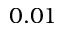Convert formula to latex. <formula><loc_0><loc_0><loc_500><loc_500>0 . 0 1</formula> 